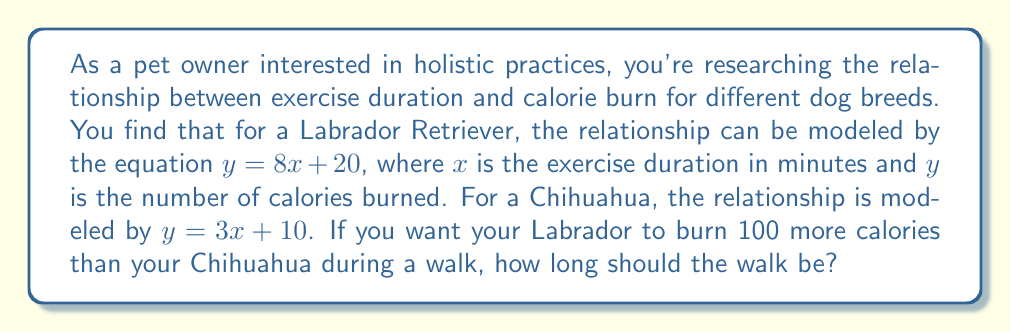Give your solution to this math problem. Let's approach this step-by-step:

1) Let $x$ be the duration of the walk in minutes.

2) For the Labrador Retriever:
   Calories burned = $8x + 20$

3) For the Chihuahua:
   Calories burned = $3x + 10$

4) We want the Labrador to burn 100 more calories than the Chihuahua. This can be expressed as:

   $(8x + 20) - (3x + 10) = 100$

5) Let's solve this equation:
   $8x + 20 - 3x - 10 = 100$
   $5x + 10 = 100$
   $5x = 90$
   $x = 18$

6) To verify:
   Labrador: $8(18) + 20 = 164$ calories
   Chihuahua: $3(18) + 10 = 64$ calories
   Difference: $164 - 64 = 100$ calories

Therefore, the walk should be 18 minutes long for the Labrador to burn 100 more calories than the Chihuahua.
Answer: 18 minutes 